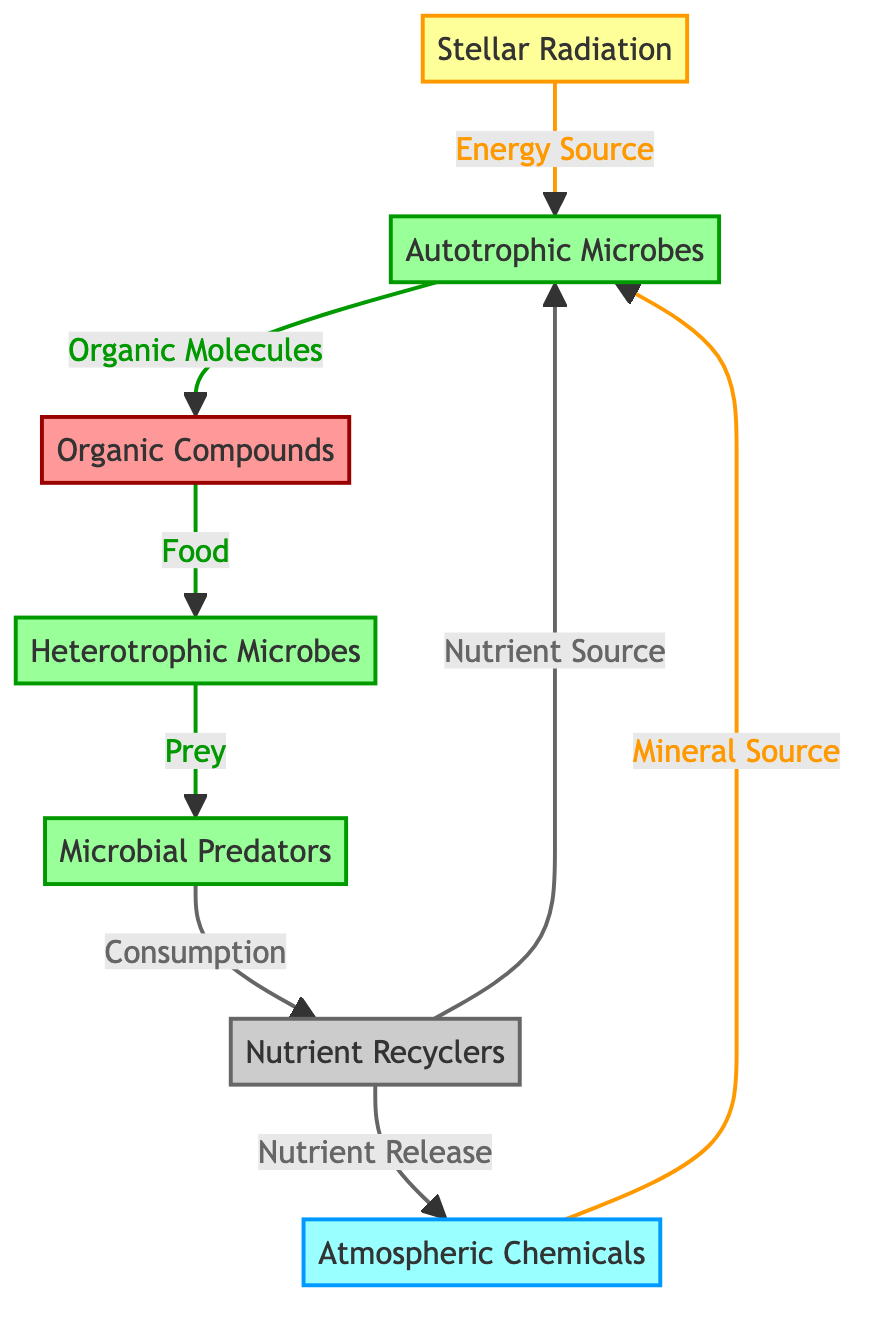What is the energy source for autotrophic microbes? The diagram shows that stellar radiation is an energy source for autotrophic microbes, as indicated by the arrow connecting Stellar Radiation to Autotrophic Microbes.
Answer: Stellar Radiation Which node is associated with atmospheric chemicals? The diagram connects Atmospheric Chemicals to Autotrophic Microbes, showing that atmospheric chemicals act as a mineral source for these microbes.
Answer: Autotrophic Microbes How many categories of microbes are depicted in the diagram? The diagram contains three different categories of microbes: Autotrophic Microbes, Heterotrophic Microbes, and Microbial Predators, totaling three separate node types.
Answer: Three What do organic compounds serve as for heterotrophic microbes? The diagram reveals that organic compounds are described as food for heterotrophic microbes, as indicated by the labeled connection from Organic Compounds to Heterotrophic Microbes.
Answer: Food What is the final outcome of nutrient release by nutrient recyclers? The diagram indicates that nutrient recyclers release nutrients back into atmospheric chemicals, indicating that they regenerate nutrient sources for autotrophic microbes.
Answer: Atmospheric Chemicals What is the relationship between heterotrophic microbes and microbial predators? The diagram shows that heterotrophic microbes serve as prey for microbial predators, indicated by the direction of the arrow pointing from Heterotrophic Microbes to Microbial Predators.
Answer: Prey Which process involves microbial predators consuming heterotrophic microbes? The diagram indicates that consumption refers to the action of microbial predators when they consume heterotrophic microbes, verified by the labeled connection from Microbial Predators to Nutrient Recyclers.
Answer: Consumption What do nutrient recyclers provide to autotrophic microbes? The diagram shows that nutrient recyclers provide nutrients to autotrophic microbes, as represented by the arrow linking Nutrient Recyclers to Autotrophic Microbes with the label "Nutrient Source."
Answer: Nutrient Source 